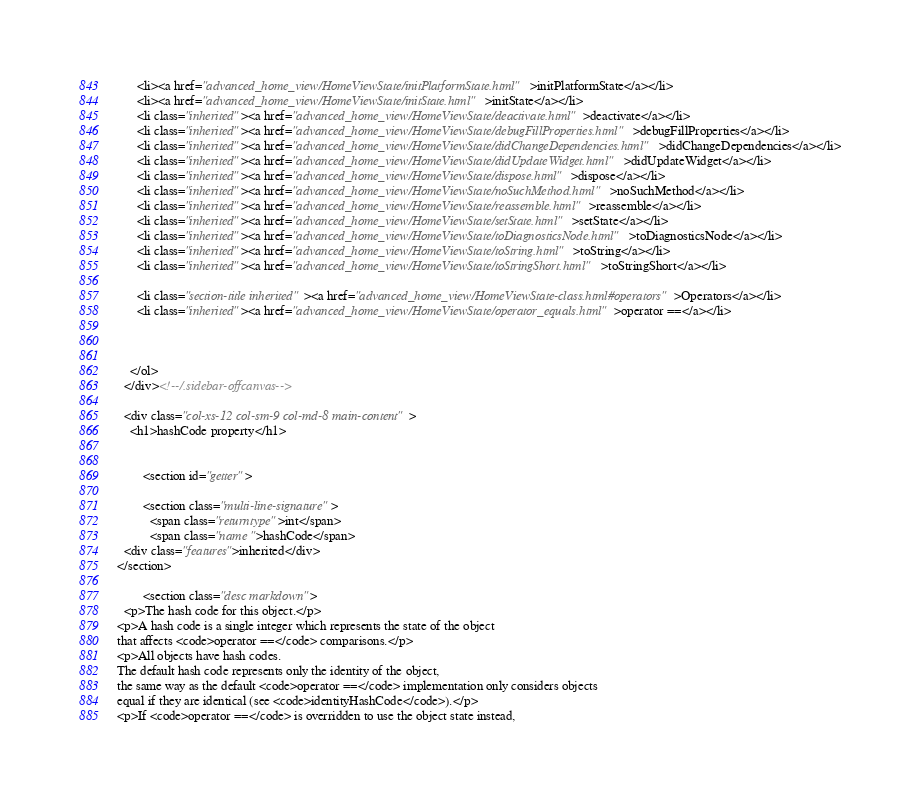<code> <loc_0><loc_0><loc_500><loc_500><_HTML_>      <li><a href="advanced_home_view/HomeViewState/initPlatformState.html">initPlatformState</a></li>
      <li><a href="advanced_home_view/HomeViewState/initState.html">initState</a></li>
      <li class="inherited"><a href="advanced_home_view/HomeViewState/deactivate.html">deactivate</a></li>
      <li class="inherited"><a href="advanced_home_view/HomeViewState/debugFillProperties.html">debugFillProperties</a></li>
      <li class="inherited"><a href="advanced_home_view/HomeViewState/didChangeDependencies.html">didChangeDependencies</a></li>
      <li class="inherited"><a href="advanced_home_view/HomeViewState/didUpdateWidget.html">didUpdateWidget</a></li>
      <li class="inherited"><a href="advanced_home_view/HomeViewState/dispose.html">dispose</a></li>
      <li class="inherited"><a href="advanced_home_view/HomeViewState/noSuchMethod.html">noSuchMethod</a></li>
      <li class="inherited"><a href="advanced_home_view/HomeViewState/reassemble.html">reassemble</a></li>
      <li class="inherited"><a href="advanced_home_view/HomeViewState/setState.html">setState</a></li>
      <li class="inherited"><a href="advanced_home_view/HomeViewState/toDiagnosticsNode.html">toDiagnosticsNode</a></li>
      <li class="inherited"><a href="advanced_home_view/HomeViewState/toString.html">toString</a></li>
      <li class="inherited"><a href="advanced_home_view/HomeViewState/toStringShort.html">toStringShort</a></li>
    
      <li class="section-title inherited"><a href="advanced_home_view/HomeViewState-class.html#operators">Operators</a></li>
      <li class="inherited"><a href="advanced_home_view/HomeViewState/operator_equals.html">operator ==</a></li>
    
    
    
    </ol>
  </div><!--/.sidebar-offcanvas-->

  <div class="col-xs-12 col-sm-9 col-md-8 main-content">
    <h1>hashCode property</h1>


        <section id="getter">
        
        <section class="multi-line-signature">
          <span class="returntype">int</span>
          <span class="name ">hashCode</span>
  <div class="features">inherited</div>
</section>
        
        <section class="desc markdown">
  <p>The hash code for this object.</p>
<p>A hash code is a single integer which represents the state of the object
that affects <code>operator ==</code> comparisons.</p>
<p>All objects have hash codes.
The default hash code represents only the identity of the object,
the same way as the default <code>operator ==</code> implementation only considers objects
equal if they are identical (see <code>identityHashCode</code>).</p>
<p>If <code>operator ==</code> is overridden to use the object state instead,</code> 